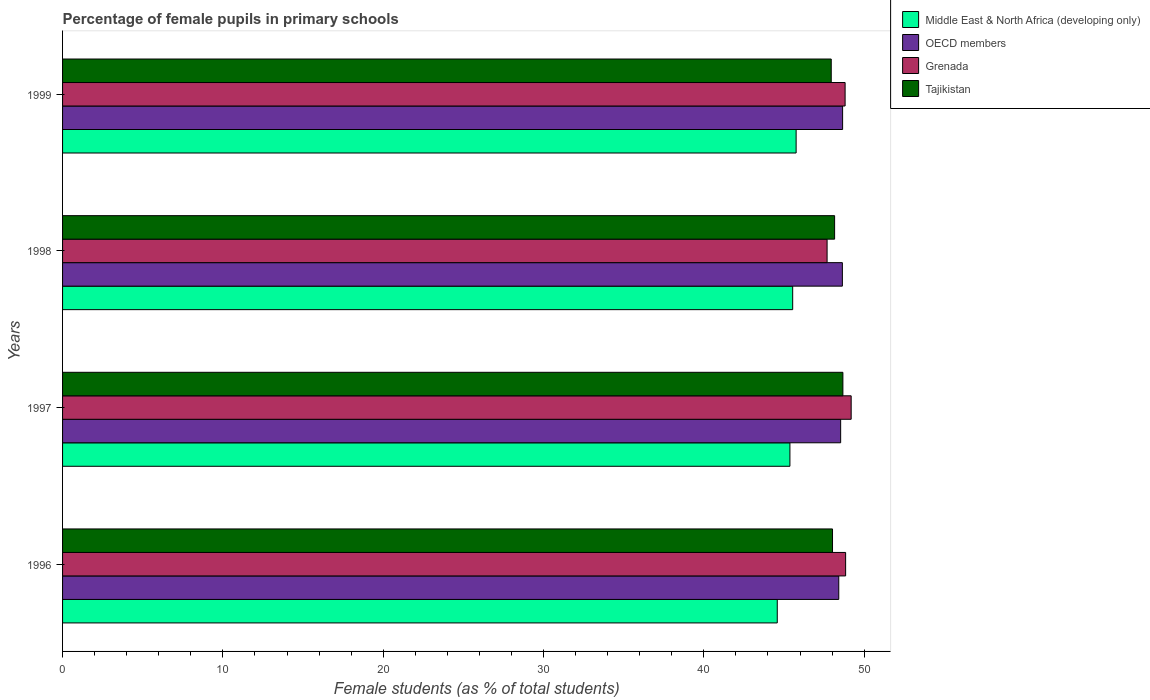Are the number of bars on each tick of the Y-axis equal?
Provide a succinct answer. Yes. How many bars are there on the 4th tick from the top?
Make the answer very short. 4. How many bars are there on the 2nd tick from the bottom?
Your response must be concise. 4. What is the label of the 4th group of bars from the top?
Your response must be concise. 1996. In how many cases, is the number of bars for a given year not equal to the number of legend labels?
Provide a succinct answer. 0. What is the percentage of female pupils in primary schools in OECD members in 1996?
Provide a short and direct response. 48.42. Across all years, what is the maximum percentage of female pupils in primary schools in Grenada?
Offer a terse response. 49.19. Across all years, what is the minimum percentage of female pupils in primary schools in Middle East & North Africa (developing only)?
Offer a very short reply. 44.58. In which year was the percentage of female pupils in primary schools in Tajikistan maximum?
Offer a very short reply. 1997. What is the total percentage of female pupils in primary schools in OECD members in the graph?
Your answer should be very brief. 194.25. What is the difference between the percentage of female pupils in primary schools in Tajikistan in 1997 and that in 1998?
Give a very brief answer. 0.52. What is the difference between the percentage of female pupils in primary schools in Tajikistan in 1998 and the percentage of female pupils in primary schools in Middle East & North Africa (developing only) in 1997?
Provide a short and direct response. 2.79. What is the average percentage of female pupils in primary schools in Grenada per year?
Provide a short and direct response. 48.63. In the year 1999, what is the difference between the percentage of female pupils in primary schools in OECD members and percentage of female pupils in primary schools in Middle East & North Africa (developing only)?
Give a very brief answer. 2.9. What is the ratio of the percentage of female pupils in primary schools in Tajikistan in 1998 to that in 1999?
Offer a terse response. 1. Is the percentage of female pupils in primary schools in OECD members in 1997 less than that in 1999?
Your response must be concise. Yes. Is the difference between the percentage of female pupils in primary schools in OECD members in 1998 and 1999 greater than the difference between the percentage of female pupils in primary schools in Middle East & North Africa (developing only) in 1998 and 1999?
Offer a very short reply. Yes. What is the difference between the highest and the second highest percentage of female pupils in primary schools in Grenada?
Offer a very short reply. 0.35. What is the difference between the highest and the lowest percentage of female pupils in primary schools in Middle East & North Africa (developing only)?
Ensure brevity in your answer.  1.18. What does the 4th bar from the top in 1996 represents?
Make the answer very short. Middle East & North Africa (developing only). What does the 1st bar from the bottom in 1999 represents?
Ensure brevity in your answer.  Middle East & North Africa (developing only). Is it the case that in every year, the sum of the percentage of female pupils in primary schools in Grenada and percentage of female pupils in primary schools in Middle East & North Africa (developing only) is greater than the percentage of female pupils in primary schools in OECD members?
Give a very brief answer. Yes. Does the graph contain any zero values?
Ensure brevity in your answer.  No. How many legend labels are there?
Offer a terse response. 4. How are the legend labels stacked?
Offer a very short reply. Vertical. What is the title of the graph?
Offer a very short reply. Percentage of female pupils in primary schools. What is the label or title of the X-axis?
Give a very brief answer. Female students (as % of total students). What is the Female students (as % of total students) of Middle East & North Africa (developing only) in 1996?
Give a very brief answer. 44.58. What is the Female students (as % of total students) of OECD members in 1996?
Offer a very short reply. 48.42. What is the Female students (as % of total students) of Grenada in 1996?
Ensure brevity in your answer.  48.85. What is the Female students (as % of total students) of Tajikistan in 1996?
Keep it short and to the point. 48.03. What is the Female students (as % of total students) of Middle East & North Africa (developing only) in 1997?
Provide a succinct answer. 45.37. What is the Female students (as % of total students) in OECD members in 1997?
Offer a terse response. 48.54. What is the Female students (as % of total students) of Grenada in 1997?
Ensure brevity in your answer.  49.19. What is the Female students (as % of total students) in Tajikistan in 1997?
Offer a very short reply. 48.68. What is the Female students (as % of total students) of Middle East & North Africa (developing only) in 1998?
Give a very brief answer. 45.54. What is the Female students (as % of total students) of OECD members in 1998?
Give a very brief answer. 48.64. What is the Female students (as % of total students) in Grenada in 1998?
Offer a very short reply. 47.69. What is the Female students (as % of total students) of Tajikistan in 1998?
Offer a very short reply. 48.16. What is the Female students (as % of total students) of Middle East & North Africa (developing only) in 1999?
Your answer should be compact. 45.76. What is the Female students (as % of total students) in OECD members in 1999?
Provide a short and direct response. 48.66. What is the Female students (as % of total students) of Grenada in 1999?
Provide a succinct answer. 48.81. What is the Female students (as % of total students) of Tajikistan in 1999?
Make the answer very short. 47.95. Across all years, what is the maximum Female students (as % of total students) of Middle East & North Africa (developing only)?
Provide a short and direct response. 45.76. Across all years, what is the maximum Female students (as % of total students) of OECD members?
Ensure brevity in your answer.  48.66. Across all years, what is the maximum Female students (as % of total students) of Grenada?
Keep it short and to the point. 49.19. Across all years, what is the maximum Female students (as % of total students) of Tajikistan?
Offer a very short reply. 48.68. Across all years, what is the minimum Female students (as % of total students) in Middle East & North Africa (developing only)?
Offer a terse response. 44.58. Across all years, what is the minimum Female students (as % of total students) of OECD members?
Provide a short and direct response. 48.42. Across all years, what is the minimum Female students (as % of total students) in Grenada?
Your response must be concise. 47.69. Across all years, what is the minimum Female students (as % of total students) of Tajikistan?
Your response must be concise. 47.95. What is the total Female students (as % of total students) in Middle East & North Africa (developing only) in the graph?
Keep it short and to the point. 181.25. What is the total Female students (as % of total students) of OECD members in the graph?
Ensure brevity in your answer.  194.25. What is the total Female students (as % of total students) in Grenada in the graph?
Your response must be concise. 194.54. What is the total Female students (as % of total students) in Tajikistan in the graph?
Your answer should be very brief. 192.81. What is the difference between the Female students (as % of total students) in Middle East & North Africa (developing only) in 1996 and that in 1997?
Provide a short and direct response. -0.79. What is the difference between the Female students (as % of total students) of OECD members in 1996 and that in 1997?
Provide a succinct answer. -0.12. What is the difference between the Female students (as % of total students) of Grenada in 1996 and that in 1997?
Ensure brevity in your answer.  -0.35. What is the difference between the Female students (as % of total students) in Tajikistan in 1996 and that in 1997?
Provide a succinct answer. -0.65. What is the difference between the Female students (as % of total students) in Middle East & North Africa (developing only) in 1996 and that in 1998?
Make the answer very short. -0.96. What is the difference between the Female students (as % of total students) in OECD members in 1996 and that in 1998?
Make the answer very short. -0.23. What is the difference between the Female students (as % of total students) in Grenada in 1996 and that in 1998?
Provide a short and direct response. 1.16. What is the difference between the Female students (as % of total students) in Tajikistan in 1996 and that in 1998?
Offer a very short reply. -0.13. What is the difference between the Female students (as % of total students) of Middle East & North Africa (developing only) in 1996 and that in 1999?
Provide a short and direct response. -1.18. What is the difference between the Female students (as % of total students) of OECD members in 1996 and that in 1999?
Your response must be concise. -0.24. What is the difference between the Female students (as % of total students) in Grenada in 1996 and that in 1999?
Offer a very short reply. 0.03. What is the difference between the Female students (as % of total students) of Tajikistan in 1996 and that in 1999?
Offer a terse response. 0.08. What is the difference between the Female students (as % of total students) in Middle East & North Africa (developing only) in 1997 and that in 1998?
Make the answer very short. -0.17. What is the difference between the Female students (as % of total students) in OECD members in 1997 and that in 1998?
Your response must be concise. -0.11. What is the difference between the Female students (as % of total students) of Grenada in 1997 and that in 1998?
Offer a very short reply. 1.5. What is the difference between the Female students (as % of total students) in Tajikistan in 1997 and that in 1998?
Keep it short and to the point. 0.52. What is the difference between the Female students (as % of total students) of Middle East & North Africa (developing only) in 1997 and that in 1999?
Keep it short and to the point. -0.39. What is the difference between the Female students (as % of total students) of OECD members in 1997 and that in 1999?
Keep it short and to the point. -0.12. What is the difference between the Female students (as % of total students) in Grenada in 1997 and that in 1999?
Your answer should be compact. 0.38. What is the difference between the Female students (as % of total students) of Tajikistan in 1997 and that in 1999?
Give a very brief answer. 0.73. What is the difference between the Female students (as % of total students) in Middle East & North Africa (developing only) in 1998 and that in 1999?
Ensure brevity in your answer.  -0.21. What is the difference between the Female students (as % of total students) in OECD members in 1998 and that in 1999?
Your answer should be very brief. -0.01. What is the difference between the Female students (as % of total students) in Grenada in 1998 and that in 1999?
Make the answer very short. -1.12. What is the difference between the Female students (as % of total students) of Tajikistan in 1998 and that in 1999?
Provide a succinct answer. 0.21. What is the difference between the Female students (as % of total students) in Middle East & North Africa (developing only) in 1996 and the Female students (as % of total students) in OECD members in 1997?
Offer a terse response. -3.95. What is the difference between the Female students (as % of total students) of Middle East & North Africa (developing only) in 1996 and the Female students (as % of total students) of Grenada in 1997?
Your answer should be very brief. -4.61. What is the difference between the Female students (as % of total students) of Middle East & North Africa (developing only) in 1996 and the Female students (as % of total students) of Tajikistan in 1997?
Ensure brevity in your answer.  -4.09. What is the difference between the Female students (as % of total students) of OECD members in 1996 and the Female students (as % of total students) of Grenada in 1997?
Your answer should be compact. -0.77. What is the difference between the Female students (as % of total students) in OECD members in 1996 and the Female students (as % of total students) in Tajikistan in 1997?
Give a very brief answer. -0.26. What is the difference between the Female students (as % of total students) of Grenada in 1996 and the Female students (as % of total students) of Tajikistan in 1997?
Your answer should be compact. 0.17. What is the difference between the Female students (as % of total students) in Middle East & North Africa (developing only) in 1996 and the Female students (as % of total students) in OECD members in 1998?
Keep it short and to the point. -4.06. What is the difference between the Female students (as % of total students) in Middle East & North Africa (developing only) in 1996 and the Female students (as % of total students) in Grenada in 1998?
Give a very brief answer. -3.11. What is the difference between the Female students (as % of total students) in Middle East & North Africa (developing only) in 1996 and the Female students (as % of total students) in Tajikistan in 1998?
Offer a very short reply. -3.58. What is the difference between the Female students (as % of total students) in OECD members in 1996 and the Female students (as % of total students) in Grenada in 1998?
Ensure brevity in your answer.  0.73. What is the difference between the Female students (as % of total students) in OECD members in 1996 and the Female students (as % of total students) in Tajikistan in 1998?
Offer a very short reply. 0.26. What is the difference between the Female students (as % of total students) in Grenada in 1996 and the Female students (as % of total students) in Tajikistan in 1998?
Offer a very short reply. 0.69. What is the difference between the Female students (as % of total students) of Middle East & North Africa (developing only) in 1996 and the Female students (as % of total students) of OECD members in 1999?
Your response must be concise. -4.08. What is the difference between the Female students (as % of total students) of Middle East & North Africa (developing only) in 1996 and the Female students (as % of total students) of Grenada in 1999?
Ensure brevity in your answer.  -4.23. What is the difference between the Female students (as % of total students) of Middle East & North Africa (developing only) in 1996 and the Female students (as % of total students) of Tajikistan in 1999?
Keep it short and to the point. -3.37. What is the difference between the Female students (as % of total students) of OECD members in 1996 and the Female students (as % of total students) of Grenada in 1999?
Your answer should be very brief. -0.4. What is the difference between the Female students (as % of total students) in OECD members in 1996 and the Female students (as % of total students) in Tajikistan in 1999?
Offer a terse response. 0.47. What is the difference between the Female students (as % of total students) in Grenada in 1996 and the Female students (as % of total students) in Tajikistan in 1999?
Give a very brief answer. 0.9. What is the difference between the Female students (as % of total students) in Middle East & North Africa (developing only) in 1997 and the Female students (as % of total students) in OECD members in 1998?
Your response must be concise. -3.27. What is the difference between the Female students (as % of total students) of Middle East & North Africa (developing only) in 1997 and the Female students (as % of total students) of Grenada in 1998?
Make the answer very short. -2.32. What is the difference between the Female students (as % of total students) of Middle East & North Africa (developing only) in 1997 and the Female students (as % of total students) of Tajikistan in 1998?
Your answer should be compact. -2.79. What is the difference between the Female students (as % of total students) of OECD members in 1997 and the Female students (as % of total students) of Grenada in 1998?
Your answer should be very brief. 0.85. What is the difference between the Female students (as % of total students) in OECD members in 1997 and the Female students (as % of total students) in Tajikistan in 1998?
Your response must be concise. 0.38. What is the difference between the Female students (as % of total students) in Grenada in 1997 and the Female students (as % of total students) in Tajikistan in 1998?
Your answer should be compact. 1.03. What is the difference between the Female students (as % of total students) in Middle East & North Africa (developing only) in 1997 and the Female students (as % of total students) in OECD members in 1999?
Provide a succinct answer. -3.29. What is the difference between the Female students (as % of total students) of Middle East & North Africa (developing only) in 1997 and the Female students (as % of total students) of Grenada in 1999?
Give a very brief answer. -3.44. What is the difference between the Female students (as % of total students) of Middle East & North Africa (developing only) in 1997 and the Female students (as % of total students) of Tajikistan in 1999?
Keep it short and to the point. -2.58. What is the difference between the Female students (as % of total students) of OECD members in 1997 and the Female students (as % of total students) of Grenada in 1999?
Make the answer very short. -0.28. What is the difference between the Female students (as % of total students) of OECD members in 1997 and the Female students (as % of total students) of Tajikistan in 1999?
Provide a short and direct response. 0.59. What is the difference between the Female students (as % of total students) in Grenada in 1997 and the Female students (as % of total students) in Tajikistan in 1999?
Your answer should be very brief. 1.24. What is the difference between the Female students (as % of total students) of Middle East & North Africa (developing only) in 1998 and the Female students (as % of total students) of OECD members in 1999?
Keep it short and to the point. -3.11. What is the difference between the Female students (as % of total students) in Middle East & North Africa (developing only) in 1998 and the Female students (as % of total students) in Grenada in 1999?
Ensure brevity in your answer.  -3.27. What is the difference between the Female students (as % of total students) in Middle East & North Africa (developing only) in 1998 and the Female students (as % of total students) in Tajikistan in 1999?
Offer a very short reply. -2.41. What is the difference between the Female students (as % of total students) of OECD members in 1998 and the Female students (as % of total students) of Grenada in 1999?
Offer a very short reply. -0.17. What is the difference between the Female students (as % of total students) of OECD members in 1998 and the Female students (as % of total students) of Tajikistan in 1999?
Your answer should be very brief. 0.69. What is the difference between the Female students (as % of total students) in Grenada in 1998 and the Female students (as % of total students) in Tajikistan in 1999?
Provide a succinct answer. -0.26. What is the average Female students (as % of total students) of Middle East & North Africa (developing only) per year?
Offer a very short reply. 45.31. What is the average Female students (as % of total students) of OECD members per year?
Your answer should be compact. 48.56. What is the average Female students (as % of total students) of Grenada per year?
Ensure brevity in your answer.  48.63. What is the average Female students (as % of total students) in Tajikistan per year?
Keep it short and to the point. 48.2. In the year 1996, what is the difference between the Female students (as % of total students) of Middle East & North Africa (developing only) and Female students (as % of total students) of OECD members?
Ensure brevity in your answer.  -3.84. In the year 1996, what is the difference between the Female students (as % of total students) of Middle East & North Africa (developing only) and Female students (as % of total students) of Grenada?
Give a very brief answer. -4.26. In the year 1996, what is the difference between the Female students (as % of total students) of Middle East & North Africa (developing only) and Female students (as % of total students) of Tajikistan?
Provide a succinct answer. -3.45. In the year 1996, what is the difference between the Female students (as % of total students) in OECD members and Female students (as % of total students) in Grenada?
Provide a short and direct response. -0.43. In the year 1996, what is the difference between the Female students (as % of total students) of OECD members and Female students (as % of total students) of Tajikistan?
Your answer should be very brief. 0.39. In the year 1996, what is the difference between the Female students (as % of total students) in Grenada and Female students (as % of total students) in Tajikistan?
Ensure brevity in your answer.  0.82. In the year 1997, what is the difference between the Female students (as % of total students) in Middle East & North Africa (developing only) and Female students (as % of total students) in OECD members?
Give a very brief answer. -3.16. In the year 1997, what is the difference between the Female students (as % of total students) of Middle East & North Africa (developing only) and Female students (as % of total students) of Grenada?
Make the answer very short. -3.82. In the year 1997, what is the difference between the Female students (as % of total students) of Middle East & North Africa (developing only) and Female students (as % of total students) of Tajikistan?
Your answer should be compact. -3.3. In the year 1997, what is the difference between the Female students (as % of total students) of OECD members and Female students (as % of total students) of Grenada?
Offer a terse response. -0.66. In the year 1997, what is the difference between the Female students (as % of total students) of OECD members and Female students (as % of total students) of Tajikistan?
Keep it short and to the point. -0.14. In the year 1997, what is the difference between the Female students (as % of total students) of Grenada and Female students (as % of total students) of Tajikistan?
Keep it short and to the point. 0.52. In the year 1998, what is the difference between the Female students (as % of total students) in Middle East & North Africa (developing only) and Female students (as % of total students) in OECD members?
Your answer should be very brief. -3.1. In the year 1998, what is the difference between the Female students (as % of total students) of Middle East & North Africa (developing only) and Female students (as % of total students) of Grenada?
Your answer should be very brief. -2.15. In the year 1998, what is the difference between the Female students (as % of total students) of Middle East & North Africa (developing only) and Female students (as % of total students) of Tajikistan?
Provide a short and direct response. -2.62. In the year 1998, what is the difference between the Female students (as % of total students) of OECD members and Female students (as % of total students) of Grenada?
Your answer should be compact. 0.95. In the year 1998, what is the difference between the Female students (as % of total students) in OECD members and Female students (as % of total students) in Tajikistan?
Offer a very short reply. 0.48. In the year 1998, what is the difference between the Female students (as % of total students) in Grenada and Female students (as % of total students) in Tajikistan?
Make the answer very short. -0.47. In the year 1999, what is the difference between the Female students (as % of total students) in Middle East & North Africa (developing only) and Female students (as % of total students) in OECD members?
Your answer should be very brief. -2.9. In the year 1999, what is the difference between the Female students (as % of total students) of Middle East & North Africa (developing only) and Female students (as % of total students) of Grenada?
Your answer should be very brief. -3.06. In the year 1999, what is the difference between the Female students (as % of total students) in Middle East & North Africa (developing only) and Female students (as % of total students) in Tajikistan?
Keep it short and to the point. -2.19. In the year 1999, what is the difference between the Female students (as % of total students) in OECD members and Female students (as % of total students) in Grenada?
Your response must be concise. -0.16. In the year 1999, what is the difference between the Female students (as % of total students) in OECD members and Female students (as % of total students) in Tajikistan?
Provide a short and direct response. 0.71. In the year 1999, what is the difference between the Female students (as % of total students) in Grenada and Female students (as % of total students) in Tajikistan?
Keep it short and to the point. 0.87. What is the ratio of the Female students (as % of total students) of Middle East & North Africa (developing only) in 1996 to that in 1997?
Your answer should be compact. 0.98. What is the ratio of the Female students (as % of total students) in Tajikistan in 1996 to that in 1997?
Give a very brief answer. 0.99. What is the ratio of the Female students (as % of total students) in Middle East & North Africa (developing only) in 1996 to that in 1998?
Give a very brief answer. 0.98. What is the ratio of the Female students (as % of total students) of OECD members in 1996 to that in 1998?
Provide a short and direct response. 1. What is the ratio of the Female students (as % of total students) of Grenada in 1996 to that in 1998?
Ensure brevity in your answer.  1.02. What is the ratio of the Female students (as % of total students) in Tajikistan in 1996 to that in 1998?
Keep it short and to the point. 1. What is the ratio of the Female students (as % of total students) of Middle East & North Africa (developing only) in 1996 to that in 1999?
Ensure brevity in your answer.  0.97. What is the ratio of the Female students (as % of total students) of Middle East & North Africa (developing only) in 1997 to that in 1998?
Make the answer very short. 1. What is the ratio of the Female students (as % of total students) in OECD members in 1997 to that in 1998?
Provide a short and direct response. 1. What is the ratio of the Female students (as % of total students) of Grenada in 1997 to that in 1998?
Your answer should be very brief. 1.03. What is the ratio of the Female students (as % of total students) of Tajikistan in 1997 to that in 1998?
Make the answer very short. 1.01. What is the ratio of the Female students (as % of total students) of Middle East & North Africa (developing only) in 1997 to that in 1999?
Offer a very short reply. 0.99. What is the ratio of the Female students (as % of total students) of Grenada in 1997 to that in 1999?
Provide a short and direct response. 1.01. What is the ratio of the Female students (as % of total students) in Tajikistan in 1997 to that in 1999?
Your response must be concise. 1.02. What is the ratio of the Female students (as % of total students) in Middle East & North Africa (developing only) in 1998 to that in 1999?
Offer a very short reply. 1. What is the ratio of the Female students (as % of total students) of OECD members in 1998 to that in 1999?
Your answer should be compact. 1. What is the ratio of the Female students (as % of total students) in Grenada in 1998 to that in 1999?
Keep it short and to the point. 0.98. What is the ratio of the Female students (as % of total students) of Tajikistan in 1998 to that in 1999?
Provide a succinct answer. 1. What is the difference between the highest and the second highest Female students (as % of total students) in Middle East & North Africa (developing only)?
Keep it short and to the point. 0.21. What is the difference between the highest and the second highest Female students (as % of total students) of OECD members?
Your answer should be very brief. 0.01. What is the difference between the highest and the second highest Female students (as % of total students) in Grenada?
Keep it short and to the point. 0.35. What is the difference between the highest and the second highest Female students (as % of total students) of Tajikistan?
Your response must be concise. 0.52. What is the difference between the highest and the lowest Female students (as % of total students) in Middle East & North Africa (developing only)?
Your response must be concise. 1.18. What is the difference between the highest and the lowest Female students (as % of total students) in OECD members?
Offer a terse response. 0.24. What is the difference between the highest and the lowest Female students (as % of total students) of Grenada?
Your answer should be very brief. 1.5. What is the difference between the highest and the lowest Female students (as % of total students) of Tajikistan?
Provide a succinct answer. 0.73. 